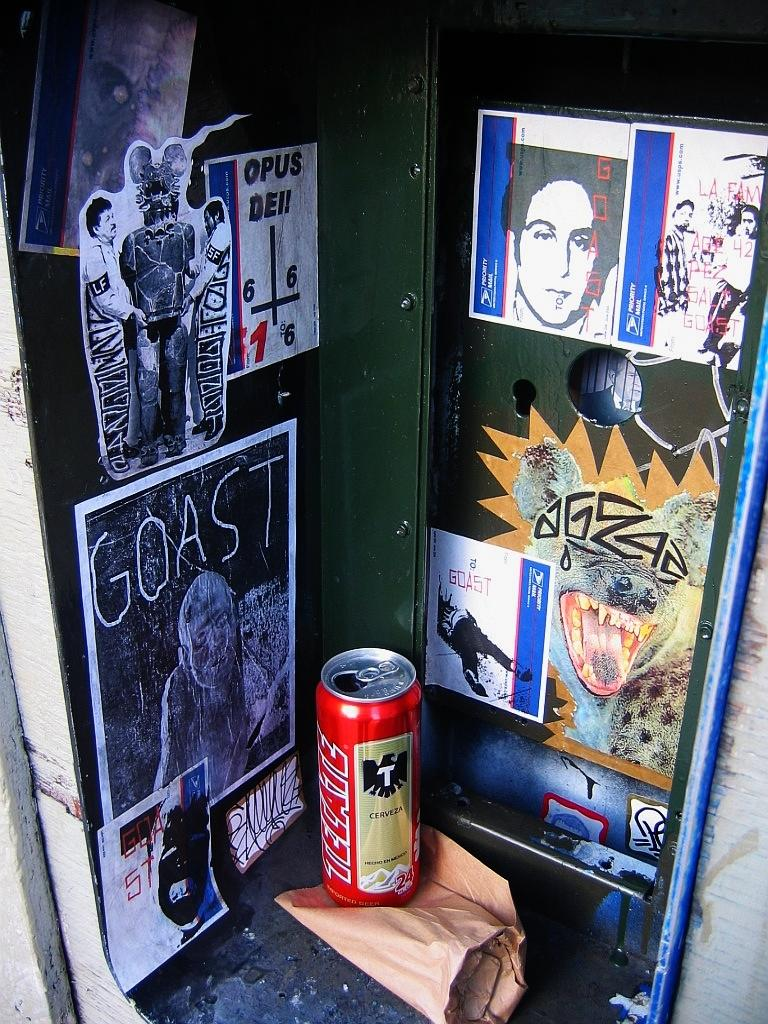<image>
Describe the image concisely. A can of Tecate beer sits in front of a wall with posters. 